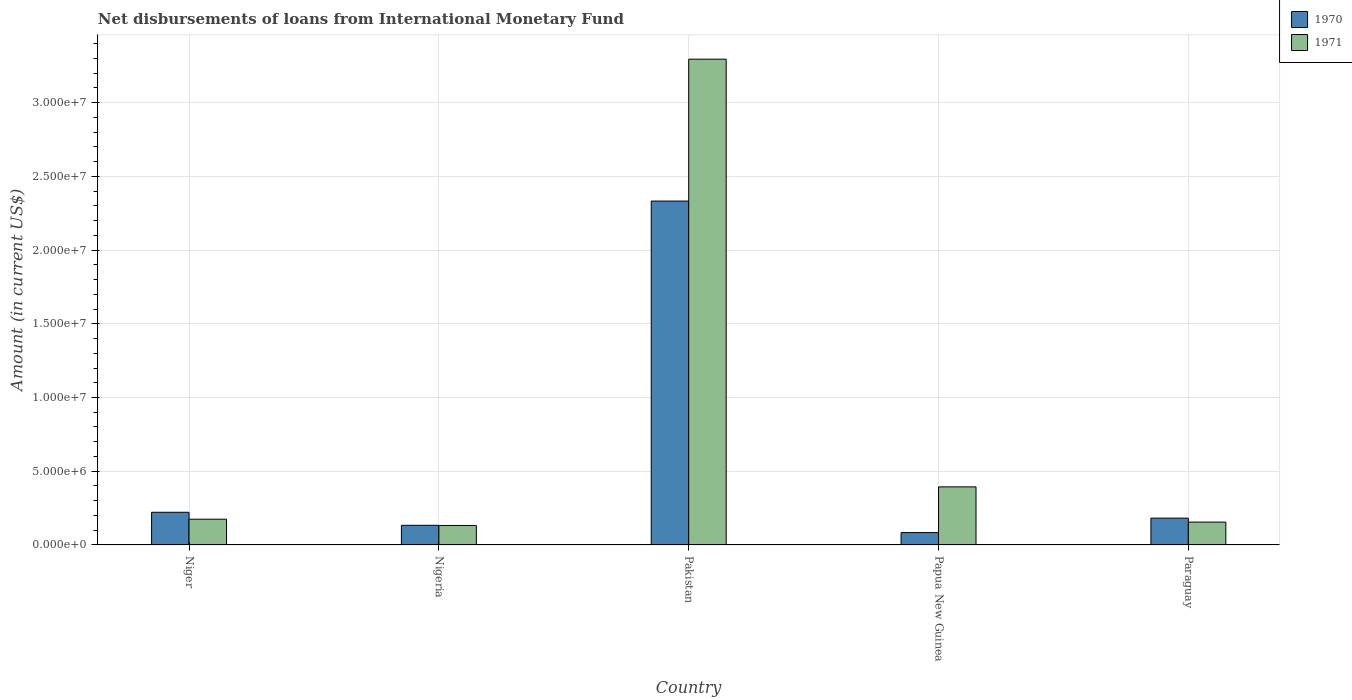How many different coloured bars are there?
Make the answer very short. 2. How many groups of bars are there?
Your response must be concise. 5. Are the number of bars per tick equal to the number of legend labels?
Your answer should be compact. Yes. Are the number of bars on each tick of the X-axis equal?
Your answer should be very brief. Yes. How many bars are there on the 5th tick from the left?
Offer a very short reply. 2. What is the label of the 5th group of bars from the left?
Provide a short and direct response. Paraguay. In how many cases, is the number of bars for a given country not equal to the number of legend labels?
Ensure brevity in your answer.  0. What is the amount of loans disbursed in 1970 in Paraguay?
Your answer should be compact. 1.82e+06. Across all countries, what is the maximum amount of loans disbursed in 1971?
Keep it short and to the point. 3.30e+07. Across all countries, what is the minimum amount of loans disbursed in 1970?
Your response must be concise. 8.37e+05. In which country was the amount of loans disbursed in 1970 maximum?
Offer a terse response. Pakistan. In which country was the amount of loans disbursed in 1971 minimum?
Ensure brevity in your answer.  Nigeria. What is the total amount of loans disbursed in 1970 in the graph?
Your answer should be very brief. 2.95e+07. What is the difference between the amount of loans disbursed in 1971 in Pakistan and that in Paraguay?
Provide a short and direct response. 3.14e+07. What is the difference between the amount of loans disbursed in 1971 in Papua New Guinea and the amount of loans disbursed in 1970 in Paraguay?
Provide a succinct answer. 2.12e+06. What is the average amount of loans disbursed in 1970 per country?
Give a very brief answer. 5.91e+06. What is the difference between the amount of loans disbursed of/in 1971 and amount of loans disbursed of/in 1970 in Niger?
Offer a terse response. -4.69e+05. What is the ratio of the amount of loans disbursed in 1970 in Niger to that in Paraguay?
Provide a succinct answer. 1.22. What is the difference between the highest and the second highest amount of loans disbursed in 1971?
Your response must be concise. 3.12e+07. What is the difference between the highest and the lowest amount of loans disbursed in 1971?
Offer a terse response. 3.16e+07. In how many countries, is the amount of loans disbursed in 1971 greater than the average amount of loans disbursed in 1971 taken over all countries?
Provide a short and direct response. 1. Is the sum of the amount of loans disbursed in 1970 in Nigeria and Paraguay greater than the maximum amount of loans disbursed in 1971 across all countries?
Offer a very short reply. No. What does the 1st bar from the left in Niger represents?
Give a very brief answer. 1970. What does the 2nd bar from the right in Pakistan represents?
Your response must be concise. 1970. How many countries are there in the graph?
Give a very brief answer. 5. Does the graph contain any zero values?
Provide a short and direct response. No. What is the title of the graph?
Give a very brief answer. Net disbursements of loans from International Monetary Fund. Does "1964" appear as one of the legend labels in the graph?
Your answer should be compact. No. What is the label or title of the X-axis?
Provide a short and direct response. Country. What is the Amount (in current US$) of 1970 in Niger?
Your answer should be very brief. 2.22e+06. What is the Amount (in current US$) in 1971 in Niger?
Provide a short and direct response. 1.75e+06. What is the Amount (in current US$) of 1970 in Nigeria?
Provide a succinct answer. 1.33e+06. What is the Amount (in current US$) in 1971 in Nigeria?
Your answer should be compact. 1.32e+06. What is the Amount (in current US$) of 1970 in Pakistan?
Your answer should be compact. 2.33e+07. What is the Amount (in current US$) in 1971 in Pakistan?
Make the answer very short. 3.30e+07. What is the Amount (in current US$) of 1970 in Papua New Guinea?
Your answer should be compact. 8.37e+05. What is the Amount (in current US$) in 1971 in Papua New Guinea?
Your response must be concise. 3.94e+06. What is the Amount (in current US$) of 1970 in Paraguay?
Make the answer very short. 1.82e+06. What is the Amount (in current US$) of 1971 in Paraguay?
Make the answer very short. 1.55e+06. Across all countries, what is the maximum Amount (in current US$) in 1970?
Your response must be concise. 2.33e+07. Across all countries, what is the maximum Amount (in current US$) of 1971?
Make the answer very short. 3.30e+07. Across all countries, what is the minimum Amount (in current US$) in 1970?
Ensure brevity in your answer.  8.37e+05. Across all countries, what is the minimum Amount (in current US$) of 1971?
Your answer should be very brief. 1.32e+06. What is the total Amount (in current US$) in 1970 in the graph?
Your answer should be very brief. 2.95e+07. What is the total Amount (in current US$) in 1971 in the graph?
Keep it short and to the point. 4.15e+07. What is the difference between the Amount (in current US$) in 1970 in Niger and that in Nigeria?
Offer a very short reply. 8.84e+05. What is the difference between the Amount (in current US$) in 1971 in Niger and that in Nigeria?
Provide a succinct answer. 4.26e+05. What is the difference between the Amount (in current US$) in 1970 in Niger and that in Pakistan?
Give a very brief answer. -2.11e+07. What is the difference between the Amount (in current US$) of 1971 in Niger and that in Pakistan?
Your answer should be very brief. -3.12e+07. What is the difference between the Amount (in current US$) of 1970 in Niger and that in Papua New Guinea?
Provide a succinct answer. 1.38e+06. What is the difference between the Amount (in current US$) in 1971 in Niger and that in Papua New Guinea?
Keep it short and to the point. -2.19e+06. What is the difference between the Amount (in current US$) in 1970 in Niger and that in Paraguay?
Make the answer very short. 3.97e+05. What is the difference between the Amount (in current US$) in 1971 in Niger and that in Paraguay?
Your response must be concise. 1.96e+05. What is the difference between the Amount (in current US$) of 1970 in Nigeria and that in Pakistan?
Your answer should be very brief. -2.20e+07. What is the difference between the Amount (in current US$) in 1971 in Nigeria and that in Pakistan?
Provide a short and direct response. -3.16e+07. What is the difference between the Amount (in current US$) in 1970 in Nigeria and that in Papua New Guinea?
Provide a short and direct response. 4.94e+05. What is the difference between the Amount (in current US$) in 1971 in Nigeria and that in Papua New Guinea?
Ensure brevity in your answer.  -2.62e+06. What is the difference between the Amount (in current US$) in 1970 in Nigeria and that in Paraguay?
Provide a short and direct response. -4.87e+05. What is the difference between the Amount (in current US$) of 1971 in Nigeria and that in Paraguay?
Keep it short and to the point. -2.30e+05. What is the difference between the Amount (in current US$) of 1970 in Pakistan and that in Papua New Guinea?
Your answer should be compact. 2.25e+07. What is the difference between the Amount (in current US$) in 1971 in Pakistan and that in Papua New Guinea?
Provide a short and direct response. 2.90e+07. What is the difference between the Amount (in current US$) in 1970 in Pakistan and that in Paraguay?
Give a very brief answer. 2.15e+07. What is the difference between the Amount (in current US$) in 1971 in Pakistan and that in Paraguay?
Your response must be concise. 3.14e+07. What is the difference between the Amount (in current US$) of 1970 in Papua New Guinea and that in Paraguay?
Offer a very short reply. -9.81e+05. What is the difference between the Amount (in current US$) of 1971 in Papua New Guinea and that in Paraguay?
Provide a short and direct response. 2.39e+06. What is the difference between the Amount (in current US$) in 1970 in Niger and the Amount (in current US$) in 1971 in Nigeria?
Provide a succinct answer. 8.95e+05. What is the difference between the Amount (in current US$) of 1970 in Niger and the Amount (in current US$) of 1971 in Pakistan?
Ensure brevity in your answer.  -3.07e+07. What is the difference between the Amount (in current US$) in 1970 in Niger and the Amount (in current US$) in 1971 in Papua New Guinea?
Give a very brief answer. -1.72e+06. What is the difference between the Amount (in current US$) in 1970 in Niger and the Amount (in current US$) in 1971 in Paraguay?
Your answer should be compact. 6.65e+05. What is the difference between the Amount (in current US$) of 1970 in Nigeria and the Amount (in current US$) of 1971 in Pakistan?
Ensure brevity in your answer.  -3.16e+07. What is the difference between the Amount (in current US$) of 1970 in Nigeria and the Amount (in current US$) of 1971 in Papua New Guinea?
Provide a short and direct response. -2.61e+06. What is the difference between the Amount (in current US$) in 1970 in Nigeria and the Amount (in current US$) in 1971 in Paraguay?
Ensure brevity in your answer.  -2.19e+05. What is the difference between the Amount (in current US$) in 1970 in Pakistan and the Amount (in current US$) in 1971 in Papua New Guinea?
Give a very brief answer. 1.94e+07. What is the difference between the Amount (in current US$) of 1970 in Pakistan and the Amount (in current US$) of 1971 in Paraguay?
Provide a short and direct response. 2.18e+07. What is the difference between the Amount (in current US$) in 1970 in Papua New Guinea and the Amount (in current US$) in 1971 in Paraguay?
Your answer should be compact. -7.13e+05. What is the average Amount (in current US$) of 1970 per country?
Give a very brief answer. 5.91e+06. What is the average Amount (in current US$) of 1971 per country?
Keep it short and to the point. 8.30e+06. What is the difference between the Amount (in current US$) of 1970 and Amount (in current US$) of 1971 in Niger?
Keep it short and to the point. 4.69e+05. What is the difference between the Amount (in current US$) in 1970 and Amount (in current US$) in 1971 in Nigeria?
Your answer should be very brief. 1.10e+04. What is the difference between the Amount (in current US$) of 1970 and Amount (in current US$) of 1971 in Pakistan?
Make the answer very short. -9.62e+06. What is the difference between the Amount (in current US$) in 1970 and Amount (in current US$) in 1971 in Papua New Guinea?
Offer a terse response. -3.10e+06. What is the difference between the Amount (in current US$) in 1970 and Amount (in current US$) in 1971 in Paraguay?
Keep it short and to the point. 2.68e+05. What is the ratio of the Amount (in current US$) of 1970 in Niger to that in Nigeria?
Offer a terse response. 1.66. What is the ratio of the Amount (in current US$) of 1971 in Niger to that in Nigeria?
Ensure brevity in your answer.  1.32. What is the ratio of the Amount (in current US$) of 1970 in Niger to that in Pakistan?
Your answer should be very brief. 0.1. What is the ratio of the Amount (in current US$) in 1971 in Niger to that in Pakistan?
Provide a succinct answer. 0.05. What is the ratio of the Amount (in current US$) in 1970 in Niger to that in Papua New Guinea?
Give a very brief answer. 2.65. What is the ratio of the Amount (in current US$) of 1971 in Niger to that in Papua New Guinea?
Ensure brevity in your answer.  0.44. What is the ratio of the Amount (in current US$) in 1970 in Niger to that in Paraguay?
Your response must be concise. 1.22. What is the ratio of the Amount (in current US$) of 1971 in Niger to that in Paraguay?
Make the answer very short. 1.13. What is the ratio of the Amount (in current US$) in 1970 in Nigeria to that in Pakistan?
Provide a short and direct response. 0.06. What is the ratio of the Amount (in current US$) in 1971 in Nigeria to that in Pakistan?
Provide a short and direct response. 0.04. What is the ratio of the Amount (in current US$) in 1970 in Nigeria to that in Papua New Guinea?
Offer a very short reply. 1.59. What is the ratio of the Amount (in current US$) in 1971 in Nigeria to that in Papua New Guinea?
Keep it short and to the point. 0.34. What is the ratio of the Amount (in current US$) in 1970 in Nigeria to that in Paraguay?
Provide a short and direct response. 0.73. What is the ratio of the Amount (in current US$) of 1971 in Nigeria to that in Paraguay?
Provide a succinct answer. 0.85. What is the ratio of the Amount (in current US$) in 1970 in Pakistan to that in Papua New Guinea?
Provide a short and direct response. 27.87. What is the ratio of the Amount (in current US$) of 1971 in Pakistan to that in Papua New Guinea?
Your answer should be very brief. 8.37. What is the ratio of the Amount (in current US$) in 1970 in Pakistan to that in Paraguay?
Offer a terse response. 12.83. What is the ratio of the Amount (in current US$) of 1971 in Pakistan to that in Paraguay?
Give a very brief answer. 21.26. What is the ratio of the Amount (in current US$) of 1970 in Papua New Guinea to that in Paraguay?
Offer a terse response. 0.46. What is the ratio of the Amount (in current US$) in 1971 in Papua New Guinea to that in Paraguay?
Make the answer very short. 2.54. What is the difference between the highest and the second highest Amount (in current US$) in 1970?
Your response must be concise. 2.11e+07. What is the difference between the highest and the second highest Amount (in current US$) in 1971?
Provide a short and direct response. 2.90e+07. What is the difference between the highest and the lowest Amount (in current US$) of 1970?
Ensure brevity in your answer.  2.25e+07. What is the difference between the highest and the lowest Amount (in current US$) of 1971?
Provide a short and direct response. 3.16e+07. 